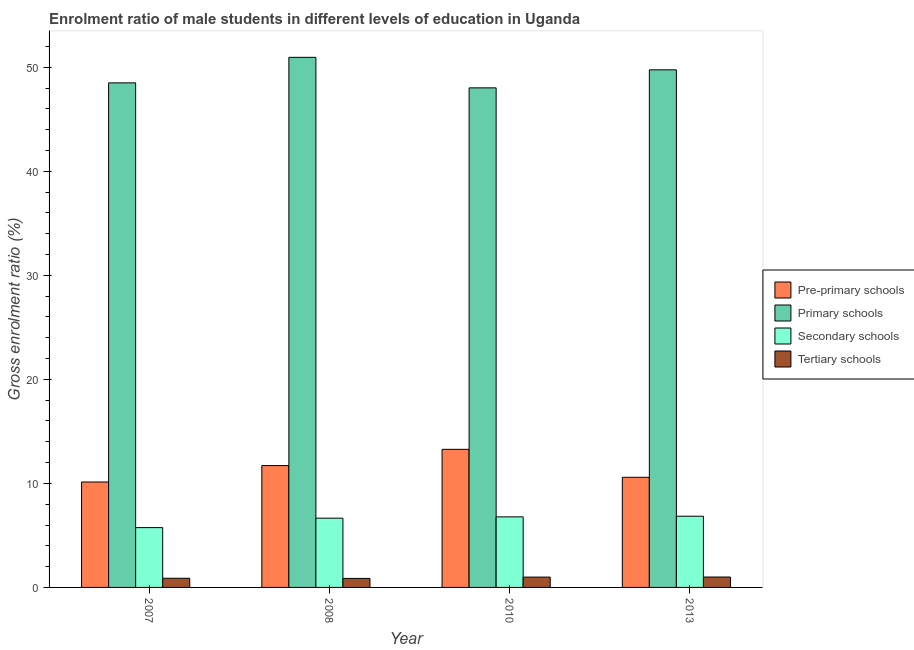How many different coloured bars are there?
Provide a succinct answer. 4. In how many cases, is the number of bars for a given year not equal to the number of legend labels?
Ensure brevity in your answer.  0. What is the gross enrolment ratio(female) in pre-primary schools in 2008?
Your answer should be very brief. 11.71. Across all years, what is the maximum gross enrolment ratio(female) in pre-primary schools?
Your answer should be very brief. 13.27. Across all years, what is the minimum gross enrolment ratio(female) in tertiary schools?
Ensure brevity in your answer.  0.87. In which year was the gross enrolment ratio(female) in secondary schools minimum?
Offer a terse response. 2007. What is the total gross enrolment ratio(female) in secondary schools in the graph?
Provide a short and direct response. 26.03. What is the difference between the gross enrolment ratio(female) in primary schools in 2008 and that in 2013?
Your answer should be compact. 1.2. What is the difference between the gross enrolment ratio(female) in tertiary schools in 2008 and the gross enrolment ratio(female) in primary schools in 2013?
Your answer should be very brief. -0.13. What is the average gross enrolment ratio(female) in tertiary schools per year?
Your answer should be very brief. 0.94. In the year 2007, what is the difference between the gross enrolment ratio(female) in pre-primary schools and gross enrolment ratio(female) in tertiary schools?
Provide a succinct answer. 0. What is the ratio of the gross enrolment ratio(female) in primary schools in 2007 to that in 2010?
Offer a terse response. 1.01. Is the difference between the gross enrolment ratio(female) in pre-primary schools in 2007 and 2013 greater than the difference between the gross enrolment ratio(female) in primary schools in 2007 and 2013?
Provide a succinct answer. No. What is the difference between the highest and the second highest gross enrolment ratio(female) in pre-primary schools?
Your answer should be compact. 1.56. What is the difference between the highest and the lowest gross enrolment ratio(female) in tertiary schools?
Offer a terse response. 0.13. In how many years, is the gross enrolment ratio(female) in primary schools greater than the average gross enrolment ratio(female) in primary schools taken over all years?
Your answer should be very brief. 2. Is the sum of the gross enrolment ratio(female) in secondary schools in 2008 and 2010 greater than the maximum gross enrolment ratio(female) in pre-primary schools across all years?
Make the answer very short. Yes. What does the 3rd bar from the left in 2013 represents?
Offer a terse response. Secondary schools. What does the 4th bar from the right in 2007 represents?
Your answer should be very brief. Pre-primary schools. Does the graph contain any zero values?
Ensure brevity in your answer.  No. Where does the legend appear in the graph?
Your answer should be very brief. Center right. How are the legend labels stacked?
Provide a succinct answer. Vertical. What is the title of the graph?
Make the answer very short. Enrolment ratio of male students in different levels of education in Uganda. What is the label or title of the X-axis?
Provide a succinct answer. Year. What is the Gross enrolment ratio (%) in Pre-primary schools in 2007?
Your response must be concise. 10.13. What is the Gross enrolment ratio (%) of Primary schools in 2007?
Offer a terse response. 48.5. What is the Gross enrolment ratio (%) in Secondary schools in 2007?
Keep it short and to the point. 5.75. What is the Gross enrolment ratio (%) of Tertiary schools in 2007?
Keep it short and to the point. 0.88. What is the Gross enrolment ratio (%) of Pre-primary schools in 2008?
Give a very brief answer. 11.71. What is the Gross enrolment ratio (%) of Primary schools in 2008?
Give a very brief answer. 50.95. What is the Gross enrolment ratio (%) in Secondary schools in 2008?
Keep it short and to the point. 6.66. What is the Gross enrolment ratio (%) in Tertiary schools in 2008?
Offer a terse response. 0.87. What is the Gross enrolment ratio (%) of Pre-primary schools in 2010?
Provide a succinct answer. 13.27. What is the Gross enrolment ratio (%) in Primary schools in 2010?
Offer a terse response. 48.02. What is the Gross enrolment ratio (%) of Secondary schools in 2010?
Your response must be concise. 6.78. What is the Gross enrolment ratio (%) of Tertiary schools in 2010?
Your answer should be compact. 0.99. What is the Gross enrolment ratio (%) of Pre-primary schools in 2013?
Make the answer very short. 10.59. What is the Gross enrolment ratio (%) in Primary schools in 2013?
Ensure brevity in your answer.  49.75. What is the Gross enrolment ratio (%) in Secondary schools in 2013?
Give a very brief answer. 6.85. What is the Gross enrolment ratio (%) of Tertiary schools in 2013?
Give a very brief answer. 1. Across all years, what is the maximum Gross enrolment ratio (%) of Pre-primary schools?
Provide a short and direct response. 13.27. Across all years, what is the maximum Gross enrolment ratio (%) in Primary schools?
Provide a succinct answer. 50.95. Across all years, what is the maximum Gross enrolment ratio (%) of Secondary schools?
Make the answer very short. 6.85. Across all years, what is the maximum Gross enrolment ratio (%) in Tertiary schools?
Give a very brief answer. 1. Across all years, what is the minimum Gross enrolment ratio (%) in Pre-primary schools?
Give a very brief answer. 10.13. Across all years, what is the minimum Gross enrolment ratio (%) of Primary schools?
Give a very brief answer. 48.02. Across all years, what is the minimum Gross enrolment ratio (%) in Secondary schools?
Provide a succinct answer. 5.75. Across all years, what is the minimum Gross enrolment ratio (%) in Tertiary schools?
Your answer should be very brief. 0.87. What is the total Gross enrolment ratio (%) in Pre-primary schools in the graph?
Your response must be concise. 45.7. What is the total Gross enrolment ratio (%) in Primary schools in the graph?
Your response must be concise. 197.22. What is the total Gross enrolment ratio (%) in Secondary schools in the graph?
Provide a succinct answer. 26.03. What is the total Gross enrolment ratio (%) in Tertiary schools in the graph?
Ensure brevity in your answer.  3.74. What is the difference between the Gross enrolment ratio (%) of Pre-primary schools in 2007 and that in 2008?
Make the answer very short. -1.58. What is the difference between the Gross enrolment ratio (%) in Primary schools in 2007 and that in 2008?
Offer a very short reply. -2.45. What is the difference between the Gross enrolment ratio (%) of Secondary schools in 2007 and that in 2008?
Give a very brief answer. -0.91. What is the difference between the Gross enrolment ratio (%) of Tertiary schools in 2007 and that in 2008?
Your answer should be compact. 0.02. What is the difference between the Gross enrolment ratio (%) of Pre-primary schools in 2007 and that in 2010?
Make the answer very short. -3.14. What is the difference between the Gross enrolment ratio (%) of Primary schools in 2007 and that in 2010?
Make the answer very short. 0.48. What is the difference between the Gross enrolment ratio (%) of Secondary schools in 2007 and that in 2010?
Give a very brief answer. -1.03. What is the difference between the Gross enrolment ratio (%) in Tertiary schools in 2007 and that in 2010?
Offer a very short reply. -0.11. What is the difference between the Gross enrolment ratio (%) of Pre-primary schools in 2007 and that in 2013?
Your answer should be compact. -0.45. What is the difference between the Gross enrolment ratio (%) in Primary schools in 2007 and that in 2013?
Your answer should be very brief. -1.25. What is the difference between the Gross enrolment ratio (%) of Secondary schools in 2007 and that in 2013?
Ensure brevity in your answer.  -1.1. What is the difference between the Gross enrolment ratio (%) in Tertiary schools in 2007 and that in 2013?
Your answer should be compact. -0.12. What is the difference between the Gross enrolment ratio (%) of Pre-primary schools in 2008 and that in 2010?
Offer a terse response. -1.56. What is the difference between the Gross enrolment ratio (%) in Primary schools in 2008 and that in 2010?
Give a very brief answer. 2.93. What is the difference between the Gross enrolment ratio (%) of Secondary schools in 2008 and that in 2010?
Offer a terse response. -0.12. What is the difference between the Gross enrolment ratio (%) of Tertiary schools in 2008 and that in 2010?
Offer a very short reply. -0.13. What is the difference between the Gross enrolment ratio (%) of Pre-primary schools in 2008 and that in 2013?
Your response must be concise. 1.13. What is the difference between the Gross enrolment ratio (%) of Primary schools in 2008 and that in 2013?
Keep it short and to the point. 1.2. What is the difference between the Gross enrolment ratio (%) of Secondary schools in 2008 and that in 2013?
Provide a succinct answer. -0.19. What is the difference between the Gross enrolment ratio (%) in Tertiary schools in 2008 and that in 2013?
Ensure brevity in your answer.  -0.13. What is the difference between the Gross enrolment ratio (%) in Pre-primary schools in 2010 and that in 2013?
Provide a short and direct response. 2.69. What is the difference between the Gross enrolment ratio (%) in Primary schools in 2010 and that in 2013?
Ensure brevity in your answer.  -1.73. What is the difference between the Gross enrolment ratio (%) in Secondary schools in 2010 and that in 2013?
Your response must be concise. -0.06. What is the difference between the Gross enrolment ratio (%) of Tertiary schools in 2010 and that in 2013?
Provide a succinct answer. -0.01. What is the difference between the Gross enrolment ratio (%) in Pre-primary schools in 2007 and the Gross enrolment ratio (%) in Primary schools in 2008?
Your answer should be very brief. -40.82. What is the difference between the Gross enrolment ratio (%) in Pre-primary schools in 2007 and the Gross enrolment ratio (%) in Secondary schools in 2008?
Make the answer very short. 3.48. What is the difference between the Gross enrolment ratio (%) in Pre-primary schools in 2007 and the Gross enrolment ratio (%) in Tertiary schools in 2008?
Give a very brief answer. 9.27. What is the difference between the Gross enrolment ratio (%) of Primary schools in 2007 and the Gross enrolment ratio (%) of Secondary schools in 2008?
Your answer should be compact. 41.84. What is the difference between the Gross enrolment ratio (%) of Primary schools in 2007 and the Gross enrolment ratio (%) of Tertiary schools in 2008?
Offer a very short reply. 47.63. What is the difference between the Gross enrolment ratio (%) in Secondary schools in 2007 and the Gross enrolment ratio (%) in Tertiary schools in 2008?
Provide a short and direct response. 4.88. What is the difference between the Gross enrolment ratio (%) of Pre-primary schools in 2007 and the Gross enrolment ratio (%) of Primary schools in 2010?
Keep it short and to the point. -37.88. What is the difference between the Gross enrolment ratio (%) in Pre-primary schools in 2007 and the Gross enrolment ratio (%) in Secondary schools in 2010?
Your answer should be compact. 3.35. What is the difference between the Gross enrolment ratio (%) of Pre-primary schools in 2007 and the Gross enrolment ratio (%) of Tertiary schools in 2010?
Your response must be concise. 9.14. What is the difference between the Gross enrolment ratio (%) in Primary schools in 2007 and the Gross enrolment ratio (%) in Secondary schools in 2010?
Give a very brief answer. 41.72. What is the difference between the Gross enrolment ratio (%) of Primary schools in 2007 and the Gross enrolment ratio (%) of Tertiary schools in 2010?
Your answer should be compact. 47.51. What is the difference between the Gross enrolment ratio (%) of Secondary schools in 2007 and the Gross enrolment ratio (%) of Tertiary schools in 2010?
Give a very brief answer. 4.76. What is the difference between the Gross enrolment ratio (%) of Pre-primary schools in 2007 and the Gross enrolment ratio (%) of Primary schools in 2013?
Provide a short and direct response. -39.62. What is the difference between the Gross enrolment ratio (%) in Pre-primary schools in 2007 and the Gross enrolment ratio (%) in Secondary schools in 2013?
Make the answer very short. 3.29. What is the difference between the Gross enrolment ratio (%) in Pre-primary schools in 2007 and the Gross enrolment ratio (%) in Tertiary schools in 2013?
Your answer should be very brief. 9.13. What is the difference between the Gross enrolment ratio (%) of Primary schools in 2007 and the Gross enrolment ratio (%) of Secondary schools in 2013?
Offer a very short reply. 41.65. What is the difference between the Gross enrolment ratio (%) of Primary schools in 2007 and the Gross enrolment ratio (%) of Tertiary schools in 2013?
Make the answer very short. 47.5. What is the difference between the Gross enrolment ratio (%) of Secondary schools in 2007 and the Gross enrolment ratio (%) of Tertiary schools in 2013?
Offer a very short reply. 4.75. What is the difference between the Gross enrolment ratio (%) of Pre-primary schools in 2008 and the Gross enrolment ratio (%) of Primary schools in 2010?
Ensure brevity in your answer.  -36.31. What is the difference between the Gross enrolment ratio (%) in Pre-primary schools in 2008 and the Gross enrolment ratio (%) in Secondary schools in 2010?
Your response must be concise. 4.93. What is the difference between the Gross enrolment ratio (%) in Pre-primary schools in 2008 and the Gross enrolment ratio (%) in Tertiary schools in 2010?
Offer a very short reply. 10.72. What is the difference between the Gross enrolment ratio (%) in Primary schools in 2008 and the Gross enrolment ratio (%) in Secondary schools in 2010?
Ensure brevity in your answer.  44.17. What is the difference between the Gross enrolment ratio (%) of Primary schools in 2008 and the Gross enrolment ratio (%) of Tertiary schools in 2010?
Offer a very short reply. 49.96. What is the difference between the Gross enrolment ratio (%) in Secondary schools in 2008 and the Gross enrolment ratio (%) in Tertiary schools in 2010?
Provide a short and direct response. 5.66. What is the difference between the Gross enrolment ratio (%) in Pre-primary schools in 2008 and the Gross enrolment ratio (%) in Primary schools in 2013?
Your response must be concise. -38.04. What is the difference between the Gross enrolment ratio (%) in Pre-primary schools in 2008 and the Gross enrolment ratio (%) in Secondary schools in 2013?
Offer a very short reply. 4.87. What is the difference between the Gross enrolment ratio (%) of Pre-primary schools in 2008 and the Gross enrolment ratio (%) of Tertiary schools in 2013?
Offer a terse response. 10.71. What is the difference between the Gross enrolment ratio (%) of Primary schools in 2008 and the Gross enrolment ratio (%) of Secondary schools in 2013?
Your answer should be compact. 44.11. What is the difference between the Gross enrolment ratio (%) in Primary schools in 2008 and the Gross enrolment ratio (%) in Tertiary schools in 2013?
Keep it short and to the point. 49.95. What is the difference between the Gross enrolment ratio (%) in Secondary schools in 2008 and the Gross enrolment ratio (%) in Tertiary schools in 2013?
Give a very brief answer. 5.66. What is the difference between the Gross enrolment ratio (%) in Pre-primary schools in 2010 and the Gross enrolment ratio (%) in Primary schools in 2013?
Provide a short and direct response. -36.48. What is the difference between the Gross enrolment ratio (%) in Pre-primary schools in 2010 and the Gross enrolment ratio (%) in Secondary schools in 2013?
Ensure brevity in your answer.  6.43. What is the difference between the Gross enrolment ratio (%) in Pre-primary schools in 2010 and the Gross enrolment ratio (%) in Tertiary schools in 2013?
Make the answer very short. 12.27. What is the difference between the Gross enrolment ratio (%) in Primary schools in 2010 and the Gross enrolment ratio (%) in Secondary schools in 2013?
Offer a very short reply. 41.17. What is the difference between the Gross enrolment ratio (%) of Primary schools in 2010 and the Gross enrolment ratio (%) of Tertiary schools in 2013?
Keep it short and to the point. 47.02. What is the difference between the Gross enrolment ratio (%) of Secondary schools in 2010 and the Gross enrolment ratio (%) of Tertiary schools in 2013?
Offer a terse response. 5.78. What is the average Gross enrolment ratio (%) of Pre-primary schools per year?
Provide a short and direct response. 11.43. What is the average Gross enrolment ratio (%) in Primary schools per year?
Your answer should be compact. 49.3. What is the average Gross enrolment ratio (%) of Secondary schools per year?
Offer a terse response. 6.51. What is the average Gross enrolment ratio (%) in Tertiary schools per year?
Offer a very short reply. 0.94. In the year 2007, what is the difference between the Gross enrolment ratio (%) of Pre-primary schools and Gross enrolment ratio (%) of Primary schools?
Offer a very short reply. -38.36. In the year 2007, what is the difference between the Gross enrolment ratio (%) of Pre-primary schools and Gross enrolment ratio (%) of Secondary schools?
Provide a succinct answer. 4.38. In the year 2007, what is the difference between the Gross enrolment ratio (%) in Pre-primary schools and Gross enrolment ratio (%) in Tertiary schools?
Offer a very short reply. 9.25. In the year 2007, what is the difference between the Gross enrolment ratio (%) of Primary schools and Gross enrolment ratio (%) of Secondary schools?
Keep it short and to the point. 42.75. In the year 2007, what is the difference between the Gross enrolment ratio (%) of Primary schools and Gross enrolment ratio (%) of Tertiary schools?
Your answer should be compact. 47.62. In the year 2007, what is the difference between the Gross enrolment ratio (%) in Secondary schools and Gross enrolment ratio (%) in Tertiary schools?
Give a very brief answer. 4.87. In the year 2008, what is the difference between the Gross enrolment ratio (%) in Pre-primary schools and Gross enrolment ratio (%) in Primary schools?
Make the answer very short. -39.24. In the year 2008, what is the difference between the Gross enrolment ratio (%) of Pre-primary schools and Gross enrolment ratio (%) of Secondary schools?
Your answer should be very brief. 5.05. In the year 2008, what is the difference between the Gross enrolment ratio (%) of Pre-primary schools and Gross enrolment ratio (%) of Tertiary schools?
Your answer should be compact. 10.84. In the year 2008, what is the difference between the Gross enrolment ratio (%) of Primary schools and Gross enrolment ratio (%) of Secondary schools?
Provide a succinct answer. 44.29. In the year 2008, what is the difference between the Gross enrolment ratio (%) in Primary schools and Gross enrolment ratio (%) in Tertiary schools?
Provide a succinct answer. 50.08. In the year 2008, what is the difference between the Gross enrolment ratio (%) of Secondary schools and Gross enrolment ratio (%) of Tertiary schools?
Provide a short and direct response. 5.79. In the year 2010, what is the difference between the Gross enrolment ratio (%) of Pre-primary schools and Gross enrolment ratio (%) of Primary schools?
Keep it short and to the point. -34.75. In the year 2010, what is the difference between the Gross enrolment ratio (%) in Pre-primary schools and Gross enrolment ratio (%) in Secondary schools?
Ensure brevity in your answer.  6.49. In the year 2010, what is the difference between the Gross enrolment ratio (%) of Pre-primary schools and Gross enrolment ratio (%) of Tertiary schools?
Provide a succinct answer. 12.28. In the year 2010, what is the difference between the Gross enrolment ratio (%) of Primary schools and Gross enrolment ratio (%) of Secondary schools?
Offer a very short reply. 41.24. In the year 2010, what is the difference between the Gross enrolment ratio (%) of Primary schools and Gross enrolment ratio (%) of Tertiary schools?
Your answer should be very brief. 47.02. In the year 2010, what is the difference between the Gross enrolment ratio (%) of Secondary schools and Gross enrolment ratio (%) of Tertiary schools?
Offer a terse response. 5.79. In the year 2013, what is the difference between the Gross enrolment ratio (%) in Pre-primary schools and Gross enrolment ratio (%) in Primary schools?
Give a very brief answer. -39.17. In the year 2013, what is the difference between the Gross enrolment ratio (%) in Pre-primary schools and Gross enrolment ratio (%) in Secondary schools?
Your answer should be compact. 3.74. In the year 2013, what is the difference between the Gross enrolment ratio (%) in Pre-primary schools and Gross enrolment ratio (%) in Tertiary schools?
Offer a very short reply. 9.58. In the year 2013, what is the difference between the Gross enrolment ratio (%) in Primary schools and Gross enrolment ratio (%) in Secondary schools?
Offer a very short reply. 42.91. In the year 2013, what is the difference between the Gross enrolment ratio (%) of Primary schools and Gross enrolment ratio (%) of Tertiary schools?
Provide a short and direct response. 48.75. In the year 2013, what is the difference between the Gross enrolment ratio (%) of Secondary schools and Gross enrolment ratio (%) of Tertiary schools?
Keep it short and to the point. 5.84. What is the ratio of the Gross enrolment ratio (%) of Pre-primary schools in 2007 to that in 2008?
Give a very brief answer. 0.87. What is the ratio of the Gross enrolment ratio (%) in Primary schools in 2007 to that in 2008?
Offer a terse response. 0.95. What is the ratio of the Gross enrolment ratio (%) of Secondary schools in 2007 to that in 2008?
Make the answer very short. 0.86. What is the ratio of the Gross enrolment ratio (%) in Tertiary schools in 2007 to that in 2008?
Offer a very short reply. 1.02. What is the ratio of the Gross enrolment ratio (%) of Pre-primary schools in 2007 to that in 2010?
Offer a very short reply. 0.76. What is the ratio of the Gross enrolment ratio (%) in Secondary schools in 2007 to that in 2010?
Provide a short and direct response. 0.85. What is the ratio of the Gross enrolment ratio (%) of Tertiary schools in 2007 to that in 2010?
Provide a succinct answer. 0.89. What is the ratio of the Gross enrolment ratio (%) of Pre-primary schools in 2007 to that in 2013?
Your answer should be very brief. 0.96. What is the ratio of the Gross enrolment ratio (%) of Primary schools in 2007 to that in 2013?
Your answer should be very brief. 0.97. What is the ratio of the Gross enrolment ratio (%) in Secondary schools in 2007 to that in 2013?
Ensure brevity in your answer.  0.84. What is the ratio of the Gross enrolment ratio (%) in Tertiary schools in 2007 to that in 2013?
Your response must be concise. 0.88. What is the ratio of the Gross enrolment ratio (%) in Pre-primary schools in 2008 to that in 2010?
Keep it short and to the point. 0.88. What is the ratio of the Gross enrolment ratio (%) in Primary schools in 2008 to that in 2010?
Your answer should be compact. 1.06. What is the ratio of the Gross enrolment ratio (%) of Secondary schools in 2008 to that in 2010?
Offer a very short reply. 0.98. What is the ratio of the Gross enrolment ratio (%) of Tertiary schools in 2008 to that in 2010?
Offer a terse response. 0.87. What is the ratio of the Gross enrolment ratio (%) in Pre-primary schools in 2008 to that in 2013?
Give a very brief answer. 1.11. What is the ratio of the Gross enrolment ratio (%) of Primary schools in 2008 to that in 2013?
Your response must be concise. 1.02. What is the ratio of the Gross enrolment ratio (%) of Secondary schools in 2008 to that in 2013?
Offer a very short reply. 0.97. What is the ratio of the Gross enrolment ratio (%) in Tertiary schools in 2008 to that in 2013?
Give a very brief answer. 0.87. What is the ratio of the Gross enrolment ratio (%) of Pre-primary schools in 2010 to that in 2013?
Provide a short and direct response. 1.25. What is the ratio of the Gross enrolment ratio (%) of Primary schools in 2010 to that in 2013?
Make the answer very short. 0.97. What is the ratio of the Gross enrolment ratio (%) in Secondary schools in 2010 to that in 2013?
Make the answer very short. 0.99. What is the ratio of the Gross enrolment ratio (%) in Tertiary schools in 2010 to that in 2013?
Give a very brief answer. 0.99. What is the difference between the highest and the second highest Gross enrolment ratio (%) in Pre-primary schools?
Offer a terse response. 1.56. What is the difference between the highest and the second highest Gross enrolment ratio (%) in Primary schools?
Ensure brevity in your answer.  1.2. What is the difference between the highest and the second highest Gross enrolment ratio (%) in Secondary schools?
Provide a succinct answer. 0.06. What is the difference between the highest and the second highest Gross enrolment ratio (%) in Tertiary schools?
Your response must be concise. 0.01. What is the difference between the highest and the lowest Gross enrolment ratio (%) in Pre-primary schools?
Make the answer very short. 3.14. What is the difference between the highest and the lowest Gross enrolment ratio (%) of Primary schools?
Ensure brevity in your answer.  2.93. What is the difference between the highest and the lowest Gross enrolment ratio (%) in Secondary schools?
Your answer should be very brief. 1.1. What is the difference between the highest and the lowest Gross enrolment ratio (%) in Tertiary schools?
Ensure brevity in your answer.  0.13. 